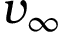<formula> <loc_0><loc_0><loc_500><loc_500>v _ { \infty }</formula> 